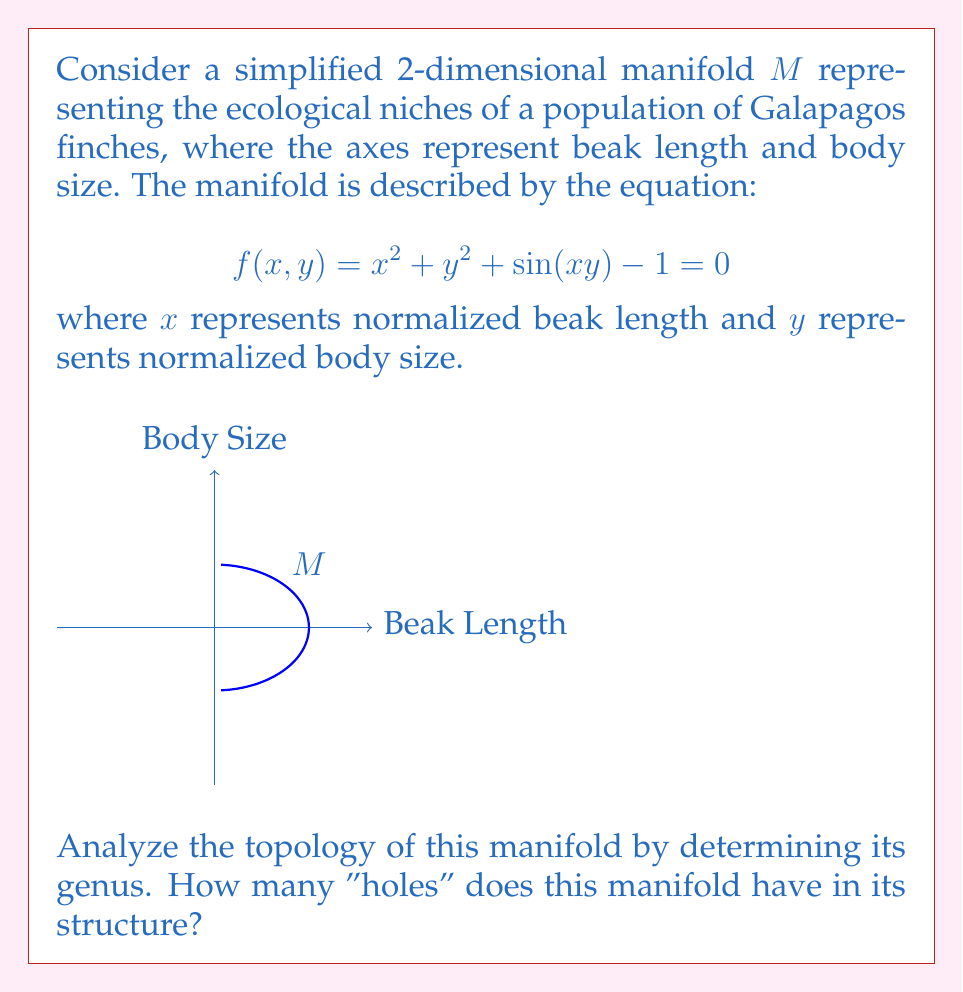What is the answer to this math problem? To determine the genus of the manifold $M$, we need to analyze its topological properties. Let's approach this step-by-step:

1) First, observe that the equation $f(x,y) = 0$ defines a closed curve in the xy-plane. This is because $x^2 + y^2 \geq 0$ for all real $x$ and $y$, and $-1 \leq \sin(xy) \leq 1$ for all real $x$ and $y$.

2) The curve is bounded because as $x^2 + y^2$ grows large, $f(x,y)$ will always be positive, so the solution must lie within a finite region.

3) The curve is connected. To see this, note that for any fixed $y$, the equation becomes a quadratic in $x$ with at most two solutions, and these solutions vary continuously with $y$.

4) The curve is smooth everywhere because $f$ is a smooth function and its gradient is non-zero everywhere on the curve:

   $$\nabla f = (2x + y\cos(xy), 2y + x\cos(xy))$$

   This vector is never $(0,0)$ on the curve.

5) By the Jordan Curve Theorem, a simple closed curve in the plane divides the plane into two regions: an "inside" and an "outside".

6) Given these properties, we can conclude that $M$ is topologically equivalent (homeomorphic) to a circle.

7) A circle is a 1-dimensional manifold with no holes, i.e., it has genus 0.

Therefore, the manifold $M$ representing the ecological niches has a genus of 0, meaning it has no holes in its structure.
Answer: Genus 0 (no holes) 